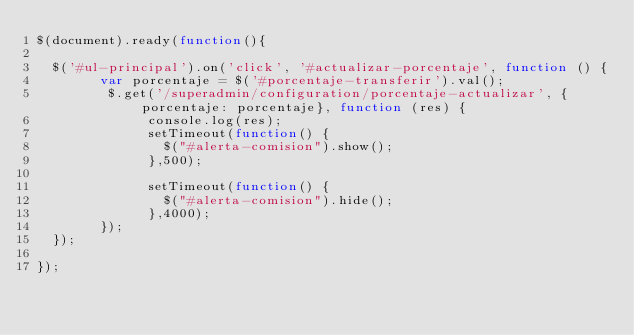<code> <loc_0><loc_0><loc_500><loc_500><_JavaScript_>$(document).ready(function(){

  $('#ul-principal').on('click', '#actualizar-porcentaje', function () {
        var porcentaje = $('#porcentaje-transferir').val();
         $.get('/superadmin/configuration/porcentaje-actualizar', {porcentaje: porcentaje}, function (res) {
              console.log(res);
              setTimeout(function() {
                $("#alerta-comision").show();
              },500);

              setTimeout(function() {
                $("#alerta-comision").hide();
              },4000);
        });
  });

});
</code> 